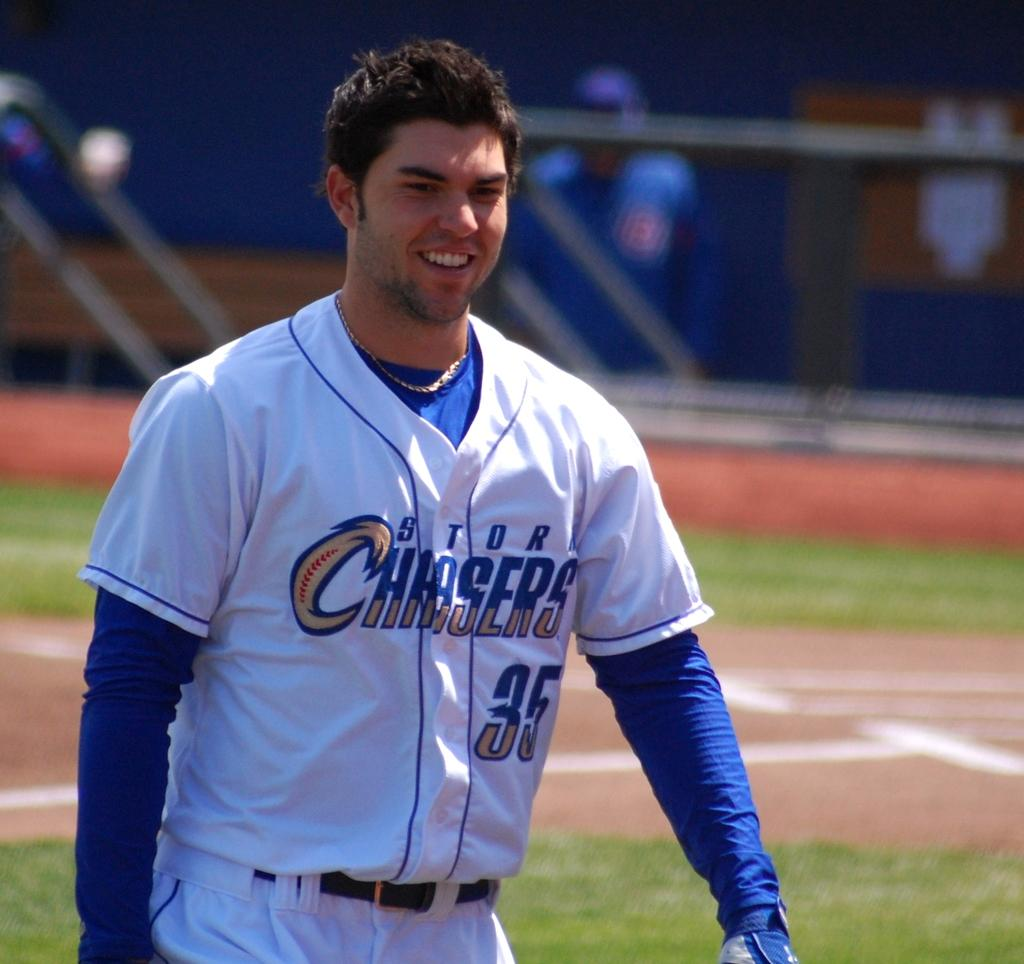<image>
Render a clear and concise summary of the photo. a happy smiling baseball player guy with STDR Chasers 35 on his uniform. 